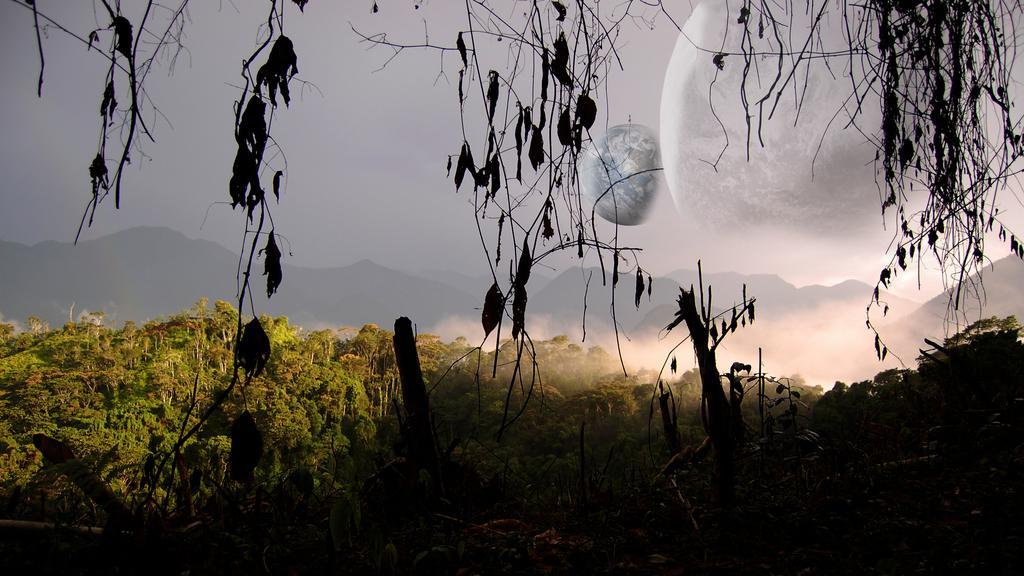In one or two sentences, can you explain what this image depicts? In this image at the bottom we can see trees and in the background there are trees. At the top we can see sky, moon and earth. 